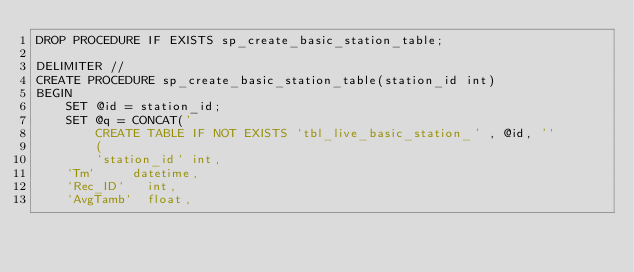Convert code to text. <code><loc_0><loc_0><loc_500><loc_500><_SQL_>DROP PROCEDURE IF EXISTS sp_create_basic_station_table;

DELIMITER //
CREATE PROCEDURE sp_create_basic_station_table(station_id int)
BEGIN
    SET @id = station_id;
    SET @q = CONCAT('
        CREATE TABLE IF NOT EXISTS `tbl_live_basic_station_' , @id, '` 
        (
        `station_id` int,
		`Tm`		 datetime,
		`Rec_ID`	 int,
		`AvgTamb`	 float,</code> 